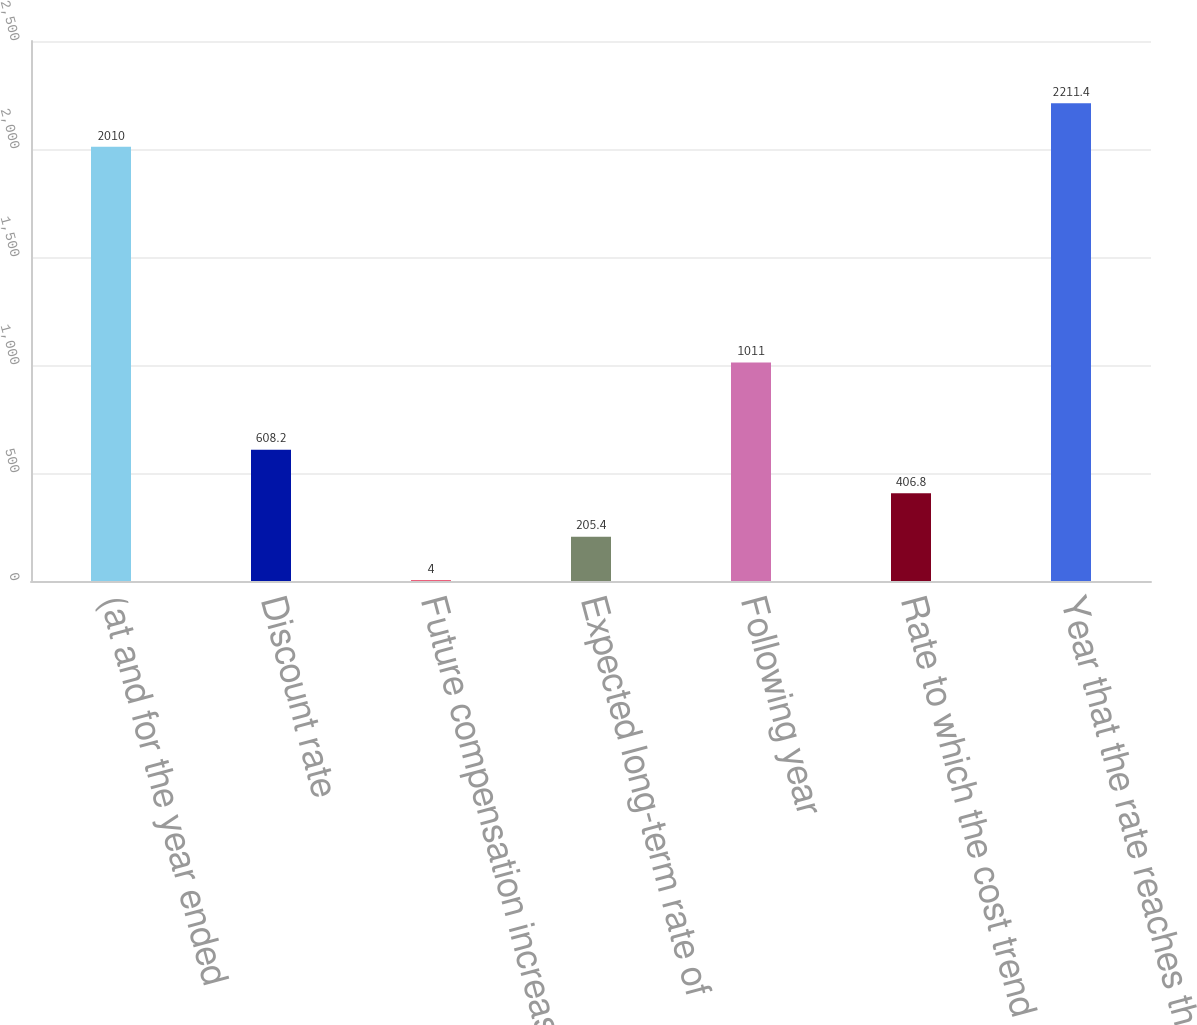<chart> <loc_0><loc_0><loc_500><loc_500><bar_chart><fcel>(at and for the year ended<fcel>Discount rate<fcel>Future compensation increase<fcel>Expected long-term rate of<fcel>Following year<fcel>Rate to which the cost trend<fcel>Year that the rate reaches the<nl><fcel>2010<fcel>608.2<fcel>4<fcel>205.4<fcel>1011<fcel>406.8<fcel>2211.4<nl></chart> 